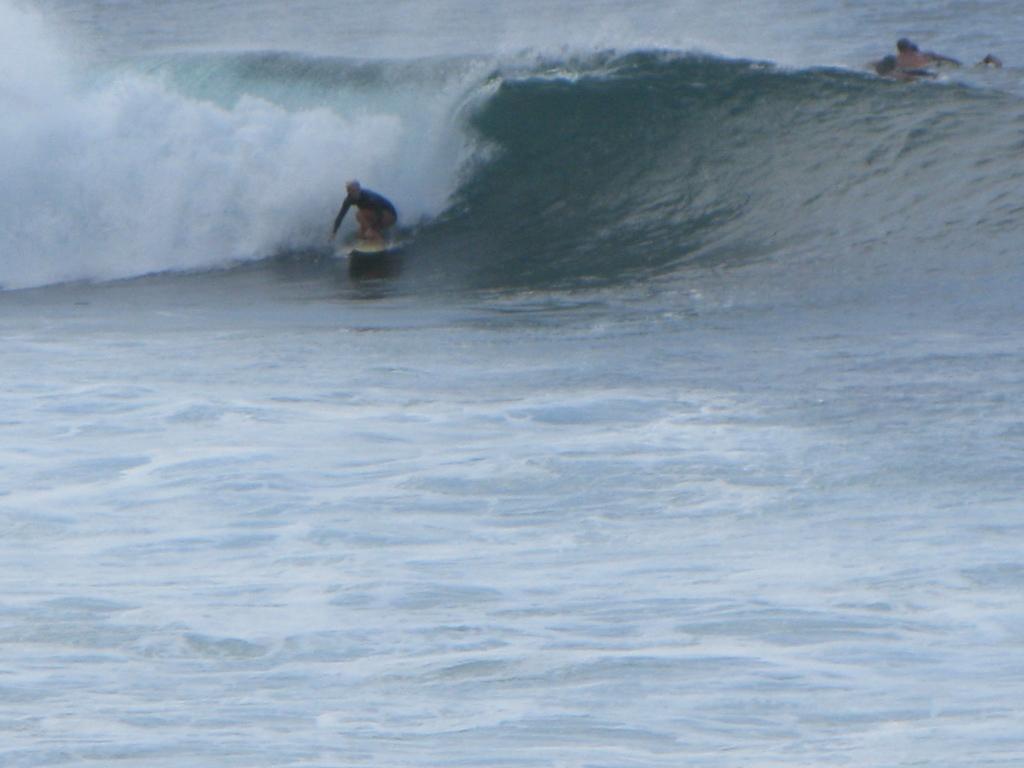Describe this image in one or two sentences. In the foreground of this image, there is a man surfing on the water. In the background, there is a person on the water. 